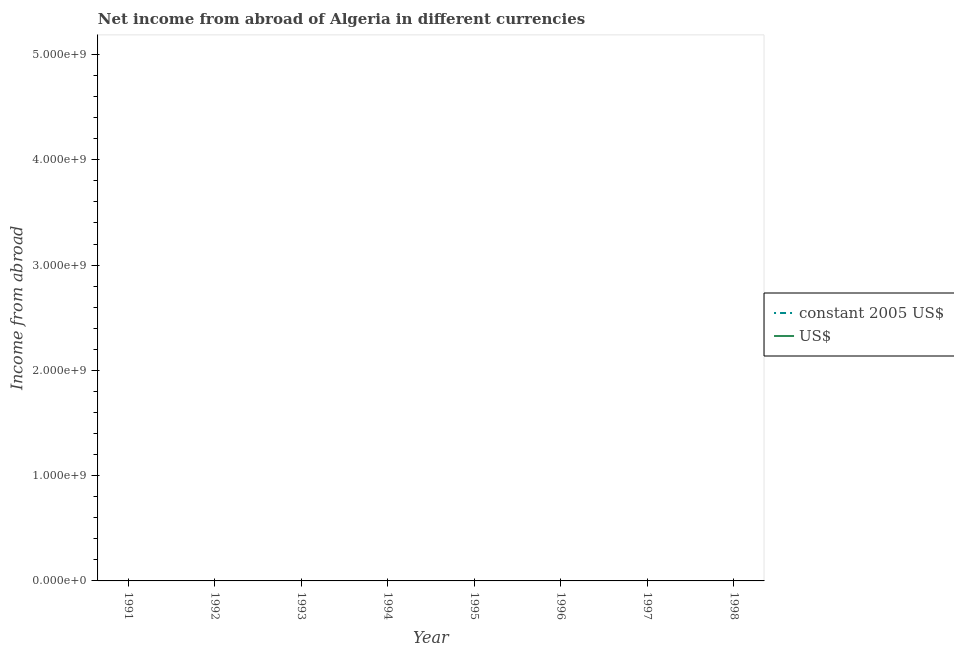How many different coloured lines are there?
Provide a short and direct response. 0. Does the line corresponding to income from abroad in us$ intersect with the line corresponding to income from abroad in constant 2005 us$?
Give a very brief answer. No. Across all years, what is the minimum income from abroad in constant 2005 us$?
Offer a terse response. 0. In how many years, is the income from abroad in us$ greater than the average income from abroad in us$ taken over all years?
Your response must be concise. 0. Is the income from abroad in us$ strictly greater than the income from abroad in constant 2005 us$ over the years?
Offer a very short reply. Yes. Is the income from abroad in constant 2005 us$ strictly less than the income from abroad in us$ over the years?
Your response must be concise. Yes. How many lines are there?
Keep it short and to the point. 0. What is the difference between two consecutive major ticks on the Y-axis?
Make the answer very short. 1.00e+09. Are the values on the major ticks of Y-axis written in scientific E-notation?
Offer a terse response. Yes. Where does the legend appear in the graph?
Your answer should be very brief. Center right. How many legend labels are there?
Keep it short and to the point. 2. How are the legend labels stacked?
Your answer should be very brief. Vertical. What is the title of the graph?
Keep it short and to the point. Net income from abroad of Algeria in different currencies. Does "Study and work" appear as one of the legend labels in the graph?
Give a very brief answer. No. What is the label or title of the X-axis?
Your answer should be very brief. Year. What is the label or title of the Y-axis?
Keep it short and to the point. Income from abroad. What is the Income from abroad in constant 2005 US$ in 1991?
Give a very brief answer. 0. What is the Income from abroad in US$ in 1992?
Your answer should be very brief. 0. What is the Income from abroad of constant 2005 US$ in 1993?
Ensure brevity in your answer.  0. What is the Income from abroad of US$ in 1993?
Offer a terse response. 0. What is the Income from abroad of constant 2005 US$ in 1995?
Ensure brevity in your answer.  0. What is the Income from abroad in US$ in 1995?
Ensure brevity in your answer.  0. What is the Income from abroad in US$ in 1996?
Your answer should be compact. 0. What is the Income from abroad of constant 2005 US$ in 1998?
Make the answer very short. 0. What is the Income from abroad of US$ in 1998?
Make the answer very short. 0. What is the total Income from abroad of constant 2005 US$ in the graph?
Offer a very short reply. 0. What is the total Income from abroad of US$ in the graph?
Give a very brief answer. 0. 